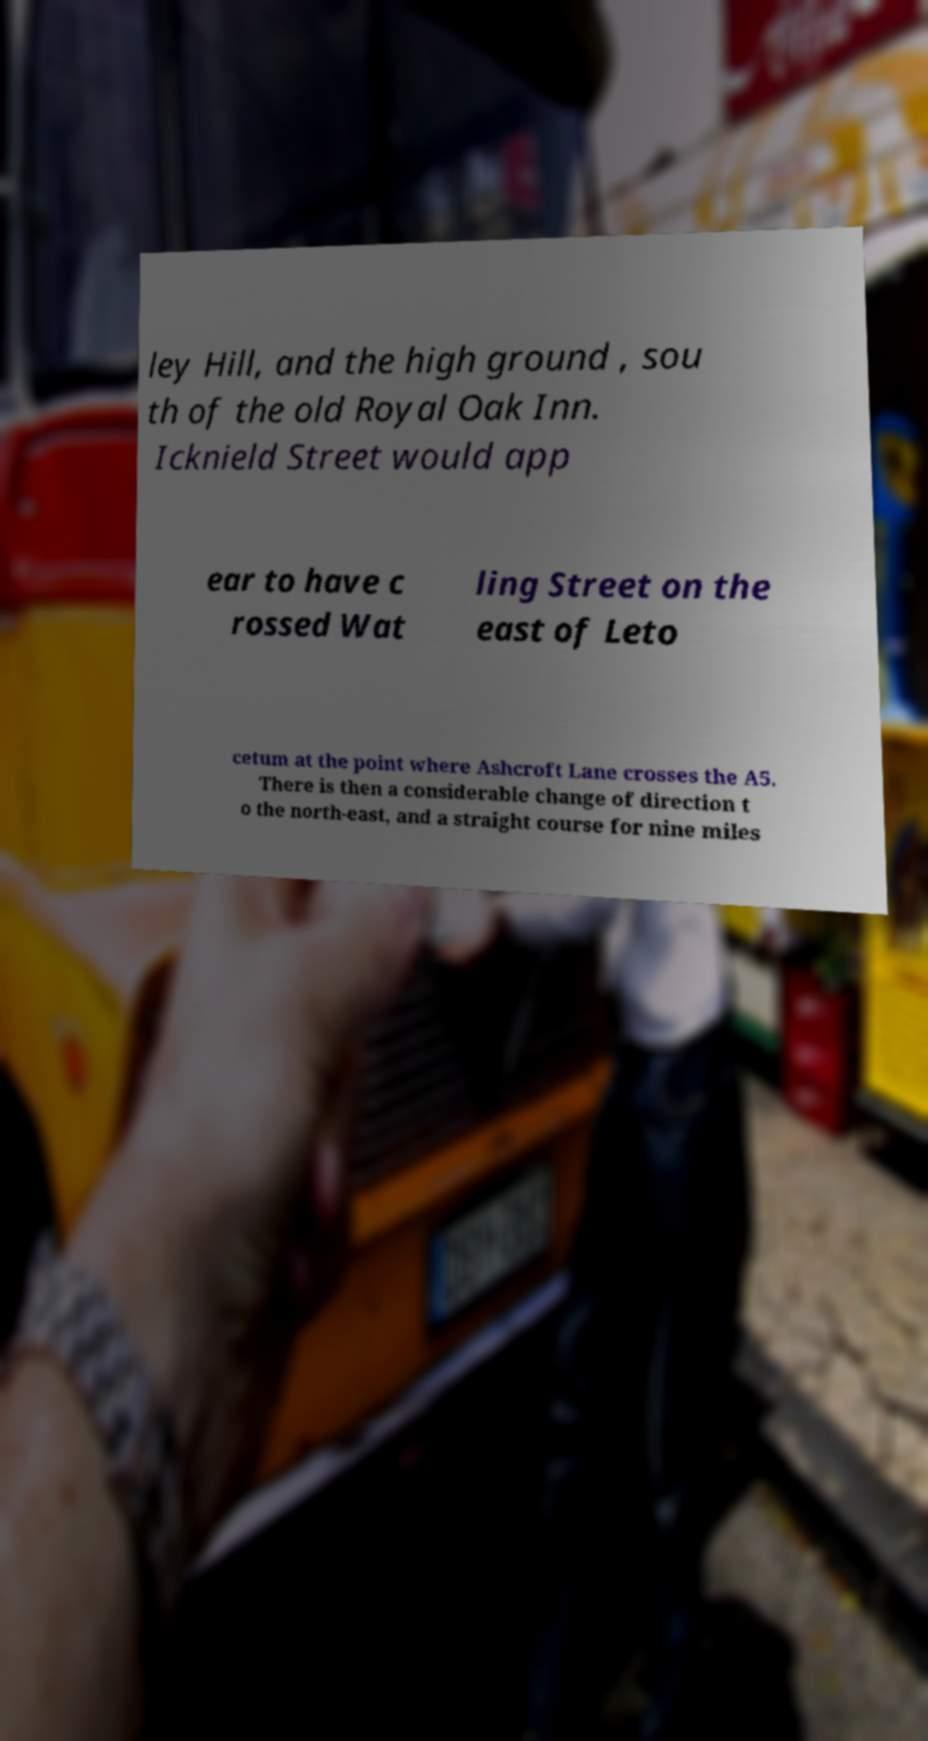Could you assist in decoding the text presented in this image and type it out clearly? ley Hill, and the high ground , sou th of the old Royal Oak Inn. Icknield Street would app ear to have c rossed Wat ling Street on the east of Leto cetum at the point where Ashcroft Lane crosses the A5. There is then a considerable change of direction t o the north-east, and a straight course for nine miles 